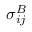Convert formula to latex. <formula><loc_0><loc_0><loc_500><loc_500>\sigma _ { i j } ^ { B }</formula> 